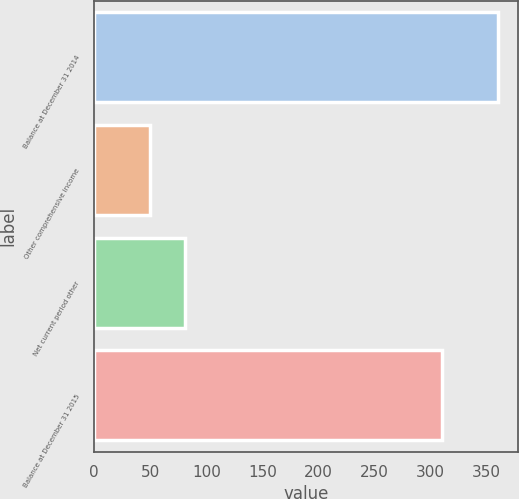Convert chart. <chart><loc_0><loc_0><loc_500><loc_500><bar_chart><fcel>Balance at December 31 2014<fcel>Other comprehensive income<fcel>Net current period other<fcel>Balance at December 31 2015<nl><fcel>360<fcel>50<fcel>81<fcel>310<nl></chart> 